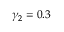Convert formula to latex. <formula><loc_0><loc_0><loc_500><loc_500>\gamma _ { 2 } = 0 . 3</formula> 